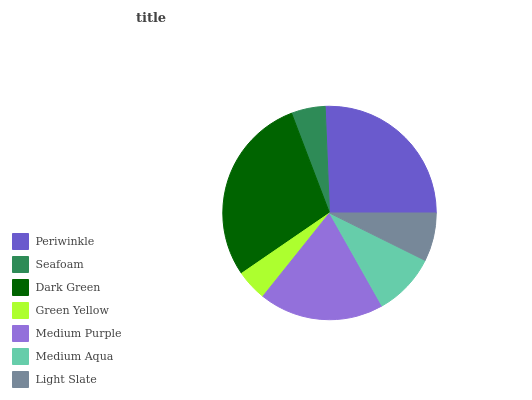Is Green Yellow the minimum?
Answer yes or no. Yes. Is Dark Green the maximum?
Answer yes or no. Yes. Is Seafoam the minimum?
Answer yes or no. No. Is Seafoam the maximum?
Answer yes or no. No. Is Periwinkle greater than Seafoam?
Answer yes or no. Yes. Is Seafoam less than Periwinkle?
Answer yes or no. Yes. Is Seafoam greater than Periwinkle?
Answer yes or no. No. Is Periwinkle less than Seafoam?
Answer yes or no. No. Is Medium Aqua the high median?
Answer yes or no. Yes. Is Medium Aqua the low median?
Answer yes or no. Yes. Is Seafoam the high median?
Answer yes or no. No. Is Dark Green the low median?
Answer yes or no. No. 